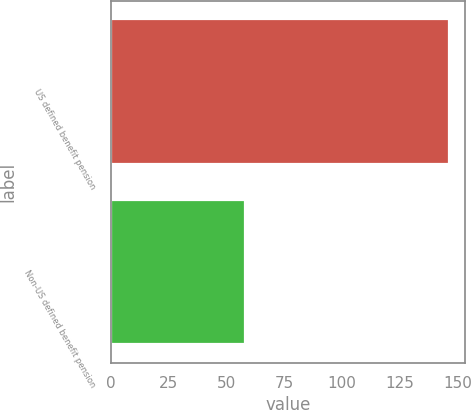<chart> <loc_0><loc_0><loc_500><loc_500><bar_chart><fcel>US defined benefit pension<fcel>Non-US defined benefit pension<nl><fcel>146<fcel>58<nl></chart> 